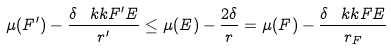Convert formula to latex. <formula><loc_0><loc_0><loc_500><loc_500>\mu ( F ^ { \prime } ) - \frac { \delta \, \ k k { F ^ { \prime } } { E } } { r ^ { \prime } } \leq \mu ( E ) - \frac { 2 \delta } { r } = \mu ( F ) - \frac { \delta \, \ k k { F } { E } } { r _ { F } }</formula> 